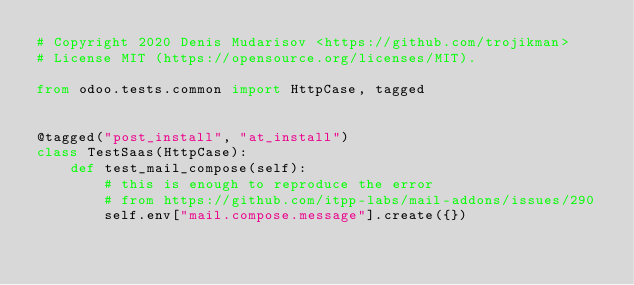<code> <loc_0><loc_0><loc_500><loc_500><_Python_># Copyright 2020 Denis Mudarisov <https://github.com/trojikman>
# License MIT (https://opensource.org/licenses/MIT).

from odoo.tests.common import HttpCase, tagged


@tagged("post_install", "at_install")
class TestSaas(HttpCase):
    def test_mail_compose(self):
        # this is enough to reproduce the error
        # from https://github.com/itpp-labs/mail-addons/issues/290
        self.env["mail.compose.message"].create({})
</code> 